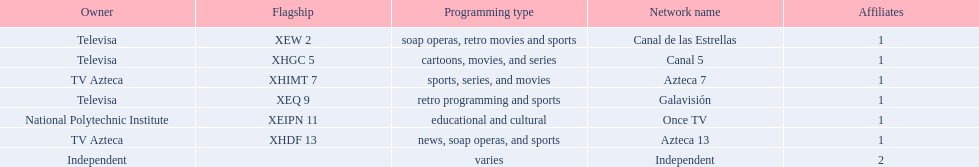What stations show sports? Soap operas, retro movies and sports, retro programming and sports, news, soap operas, and sports. What of these is not affiliated with televisa? Azteca 7. 